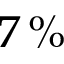<formula> <loc_0><loc_0><loc_500><loc_500>7 \, \%</formula> 